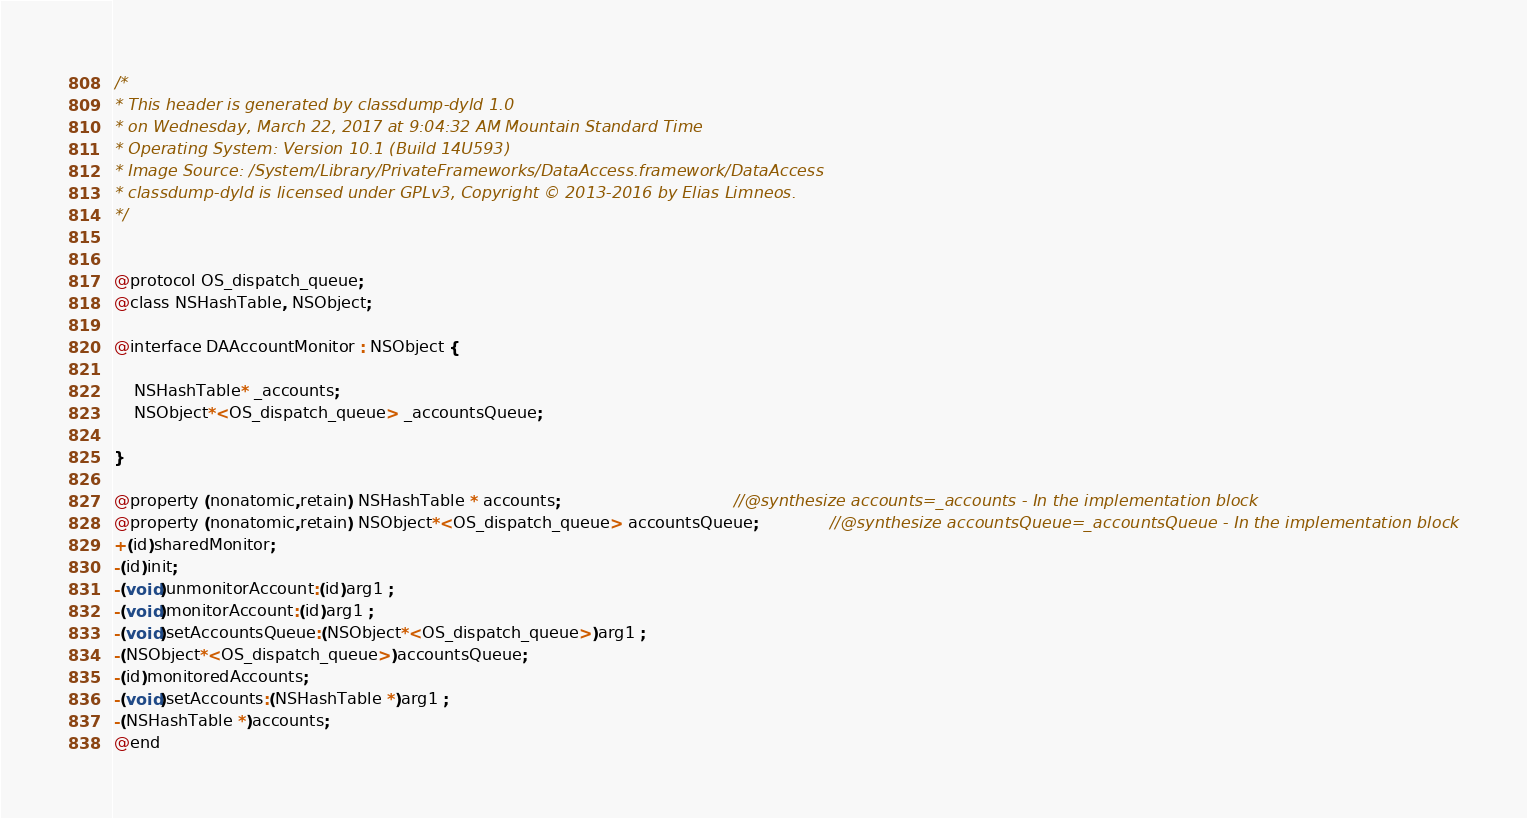Convert code to text. <code><loc_0><loc_0><loc_500><loc_500><_C_>/*
* This header is generated by classdump-dyld 1.0
* on Wednesday, March 22, 2017 at 9:04:32 AM Mountain Standard Time
* Operating System: Version 10.1 (Build 14U593)
* Image Source: /System/Library/PrivateFrameworks/DataAccess.framework/DataAccess
* classdump-dyld is licensed under GPLv3, Copyright © 2013-2016 by Elias Limneos.
*/


@protocol OS_dispatch_queue;
@class NSHashTable, NSObject;

@interface DAAccountMonitor : NSObject {

	NSHashTable* _accounts;
	NSObject*<OS_dispatch_queue> _accountsQueue;

}

@property (nonatomic,retain) NSHashTable * accounts;                                  //@synthesize accounts=_accounts - In the implementation block
@property (nonatomic,retain) NSObject*<OS_dispatch_queue> accountsQueue;              //@synthesize accountsQueue=_accountsQueue - In the implementation block
+(id)sharedMonitor;
-(id)init;
-(void)unmonitorAccount:(id)arg1 ;
-(void)monitorAccount:(id)arg1 ;
-(void)setAccountsQueue:(NSObject*<OS_dispatch_queue>)arg1 ;
-(NSObject*<OS_dispatch_queue>)accountsQueue;
-(id)monitoredAccounts;
-(void)setAccounts:(NSHashTable *)arg1 ;
-(NSHashTable *)accounts;
@end

</code> 